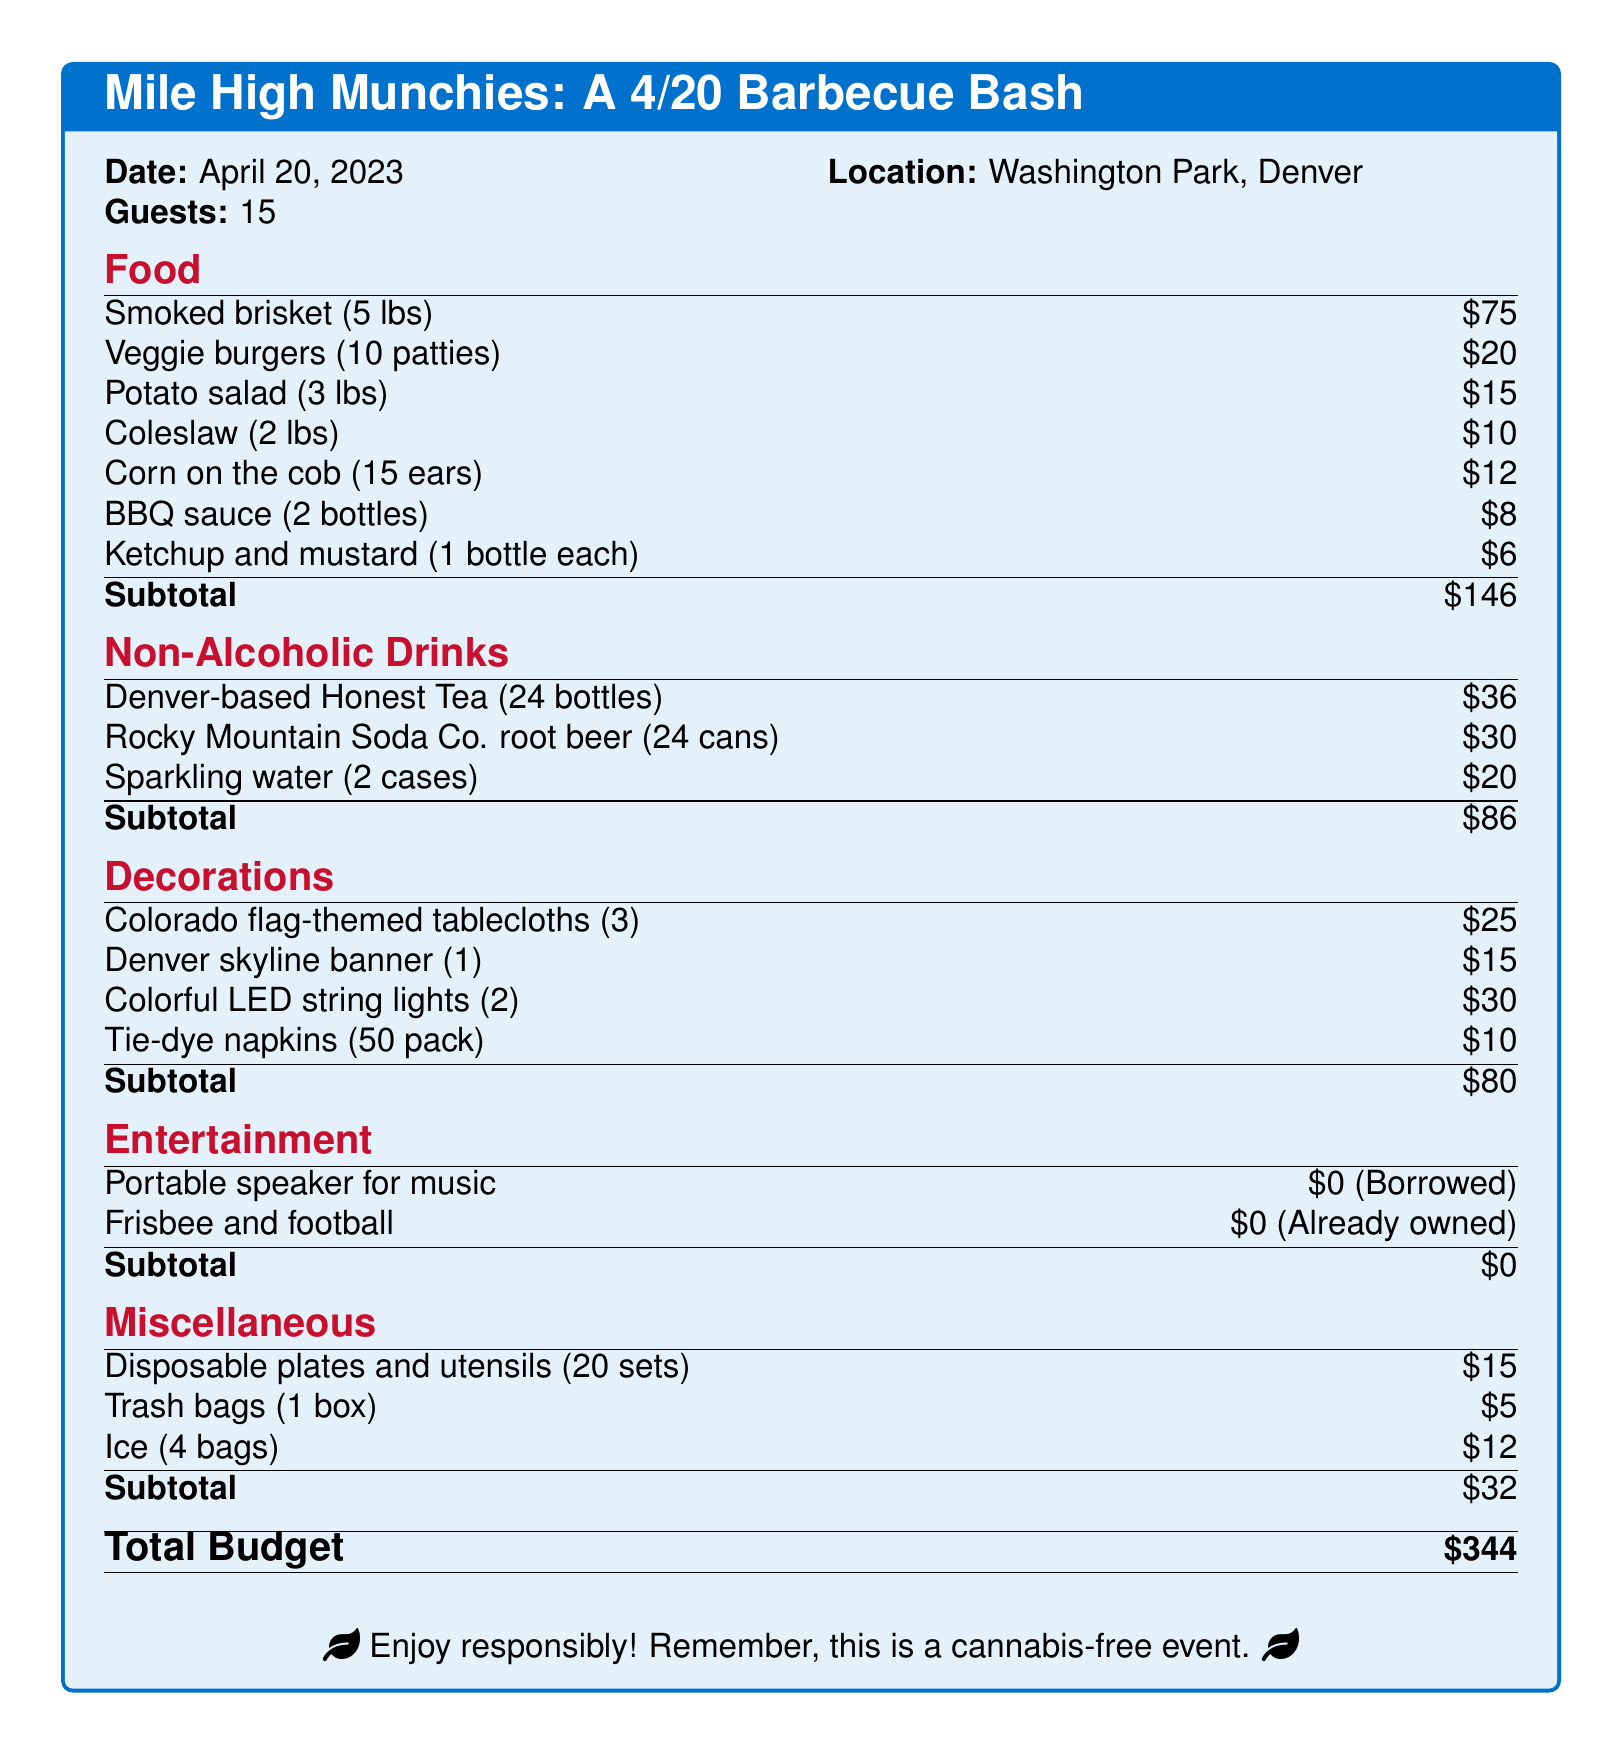What is the date of the barbecue? The document specifies the date for the barbecue as April 20, 2023.
Answer: April 20, 2023 How many guests are invited? The document indicates that there are 15 guests for the event.
Answer: 15 What is the total budget for the event? The document lists the total budget at the bottom as $344.
Answer: $344 How much is spent on non-alcoholic drinks? The document details the subtotal for non-alcoholic drinks as $86.
Answer: $86 What type of lighting is included in the decorations? The decorations section lists colorful LED string lights, indicating their inclusion in the budget.
Answer: Colorful LED string lights How much is allocated for food? The subtotal for food items is provided in the document as $146.
Answer: $146 How many ears of corn are included in the food section? The document specifies that 15 ears of corn on the cob are part of the food menu.
Answer: 15 ears What item is borrowed for entertainment? The document mentions that a portable speaker for music is borrowed for the event.
Answer: Portable speaker What is the name of a Denver-based drink included in the drinks section? Honest Tea is indicated as a Denver-based drink option in the non-alcoholic drinks section.
Answer: Honest Tea How many sets of disposable plates and utensils are included? The document states that there are 20 sets of disposable plates and utensils included in the miscellaneous section.
Answer: 20 sets 